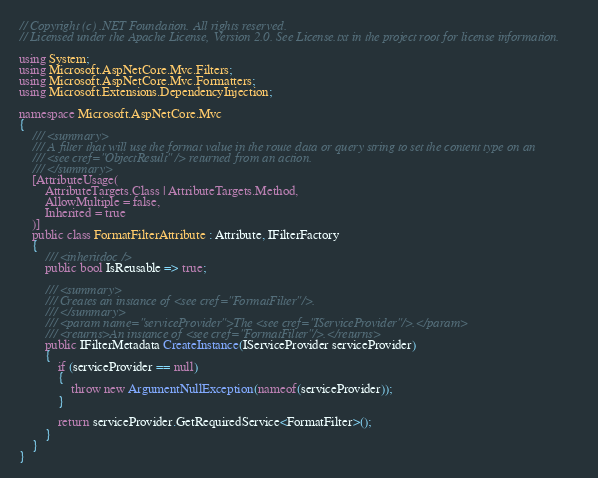<code> <loc_0><loc_0><loc_500><loc_500><_C#_>// Copyright (c) .NET Foundation. All rights reserved.
// Licensed under the Apache License, Version 2.0. See License.txt in the project root for license information.

using System;
using Microsoft.AspNetCore.Mvc.Filters;
using Microsoft.AspNetCore.Mvc.Formatters;
using Microsoft.Extensions.DependencyInjection;

namespace Microsoft.AspNetCore.Mvc
{
    /// <summary>
    /// A filter that will use the format value in the route data or query string to set the content type on an
    /// <see cref="ObjectResult" /> returned from an action.
    /// </summary>
    [AttributeUsage(
        AttributeTargets.Class | AttributeTargets.Method,
        AllowMultiple = false,
        Inherited = true
    )]
    public class FormatFilterAttribute : Attribute, IFilterFactory
    {
        /// <inheritdoc />
        public bool IsReusable => true;

        /// <summary>
        /// Creates an instance of <see cref="FormatFilter"/>.
        /// </summary>
        /// <param name="serviceProvider">The <see cref="IServiceProvider"/>.</param>
        /// <returns>An instance of <see cref="FormatFilter"/>.</returns>
        public IFilterMetadata CreateInstance(IServiceProvider serviceProvider)
        {
            if (serviceProvider == null)
            {
                throw new ArgumentNullException(nameof(serviceProvider));
            }

            return serviceProvider.GetRequiredService<FormatFilter>();
        }
    }
}
</code> 